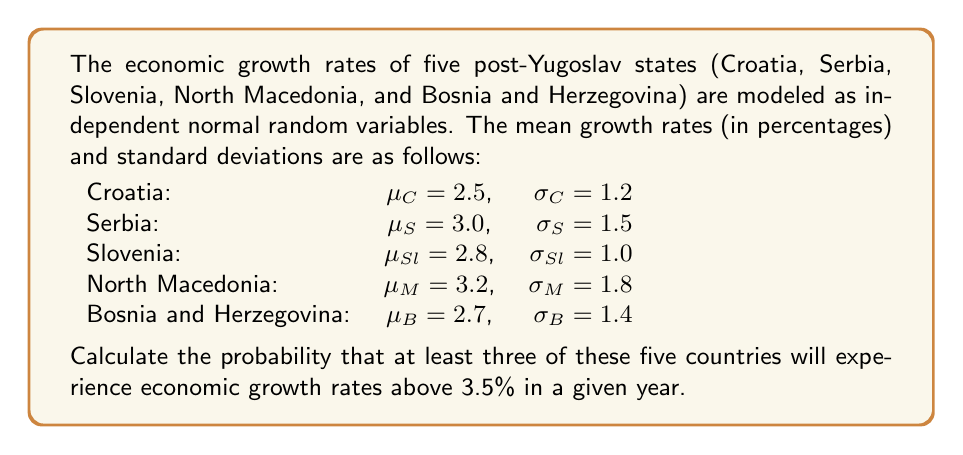Give your solution to this math problem. To solve this problem, we'll follow these steps:

1. Calculate the probability of each country having a growth rate above 3.5%.
2. Use the binomial distribution to find the probability of at least three countries exceeding 3.5% growth.

Step 1: Calculating individual probabilities

For each country, we need to find $P(X > 3.5)$, where X is the growth rate. We can standardize this to a Z-score and use the standard normal distribution.

For Croatia:
$Z_C = \frac{3.5 - \mu_C}{\sigma_C} = \frac{3.5 - 2.5}{1.2} = 0.8333$
$P(X_C > 3.5) = 1 - \Phi(0.8333) = 0.2023$

For Serbia:
$Z_S = \frac{3.5 - \mu_S}{\sigma_S} = \frac{3.5 - 3.0}{1.5} = 0.3333$
$P(X_S > 3.5) = 1 - \Phi(0.3333) = 0.3694$

For Slovenia:
$Z_{Sl} = \frac{3.5 - \mu_{Sl}}{\sigma_{Sl}} = \frac{3.5 - 2.8}{1.0} = 0.7000$
$P(X_{Sl} > 3.5) = 1 - \Phi(0.7000) = 0.2420$

For North Macedonia:
$Z_M = \frac{3.5 - \mu_M}{\sigma_M} = \frac{3.5 - 3.2}{1.8} = 0.1667$
$P(X_M > 3.5) = 1 - \Phi(0.1667) = 0.4338$

For Bosnia and Herzegovina:
$Z_B = \frac{3.5 - \mu_B}{\sigma_B} = \frac{3.5 - 2.7}{1.4} = 0.5714$
$P(X_B > 3.5) = 1 - \Phi(0.5714) = 0.2838$

Step 2: Using the binomial distribution

Let Y be the number of countries with growth rates above 3.5%. Y follows a binomial distribution with n = 5 and p = average of individual probabilities.

$p = \frac{0.2023 + 0.3694 + 0.2420 + 0.4338 + 0.2838}{5} = 0.3063$

We want $P(Y \geq 3)$, which is equal to $1 - P(Y \leq 2)$

$P(Y \geq 3) = 1 - [P(Y=0) + P(Y=1) + P(Y=2)]$

$P(Y \geq 3) = 1 - [\binom{5}{0}(0.3063)^0(0.6937)^5 + \binom{5}{1}(0.3063)^1(0.6937)^4 + \binom{5}{2}(0.3063)^2(0.6937)^3]$

$P(Y \geq 3) = 1 - [0.1659 + 0.3665 + 0.3239] = 1 - 0.8563 = 0.1437$
Answer: The probability that at least three of the five post-Yugoslav states will experience economic growth rates above 3.5% in a given year is approximately 0.1437 or 14.37%. 